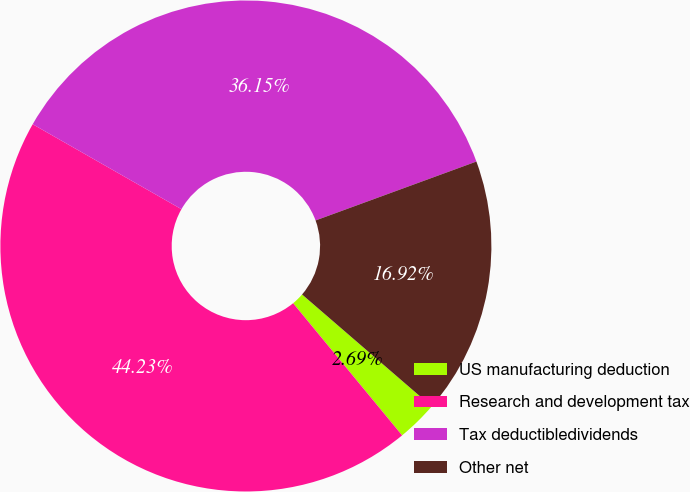Convert chart. <chart><loc_0><loc_0><loc_500><loc_500><pie_chart><fcel>US manufacturing deduction<fcel>Research and development tax<fcel>Tax deductibledividends<fcel>Other net<nl><fcel>2.69%<fcel>44.23%<fcel>36.15%<fcel>16.92%<nl></chart> 